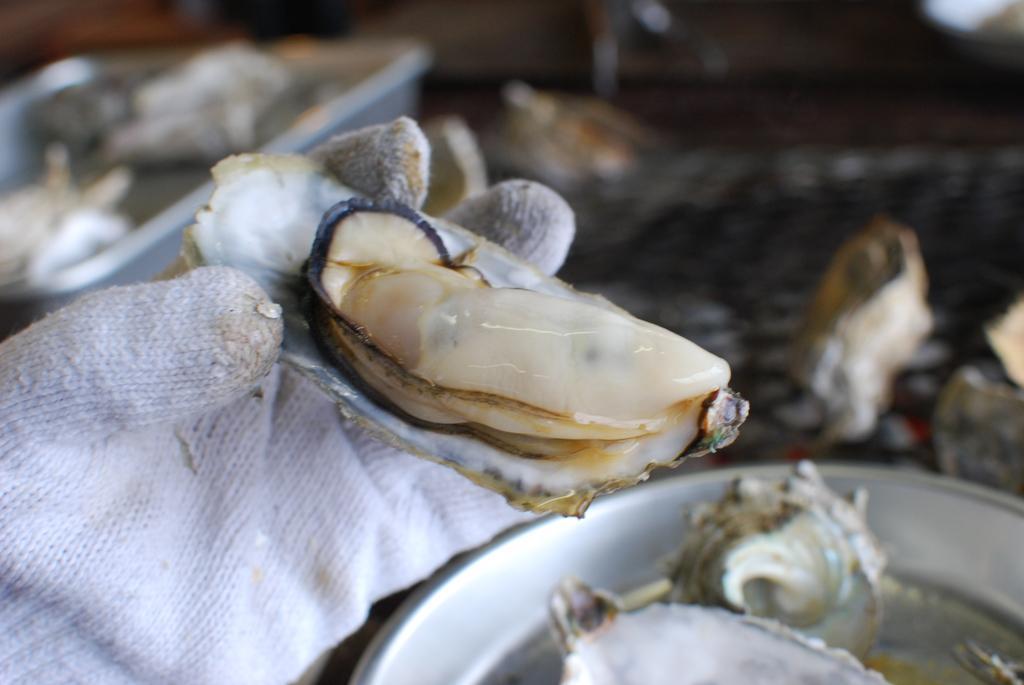How would you summarize this image in a sentence or two? In this image there is a hand with a glove holding something. On the floor on plates there are something. The background is blurry. 